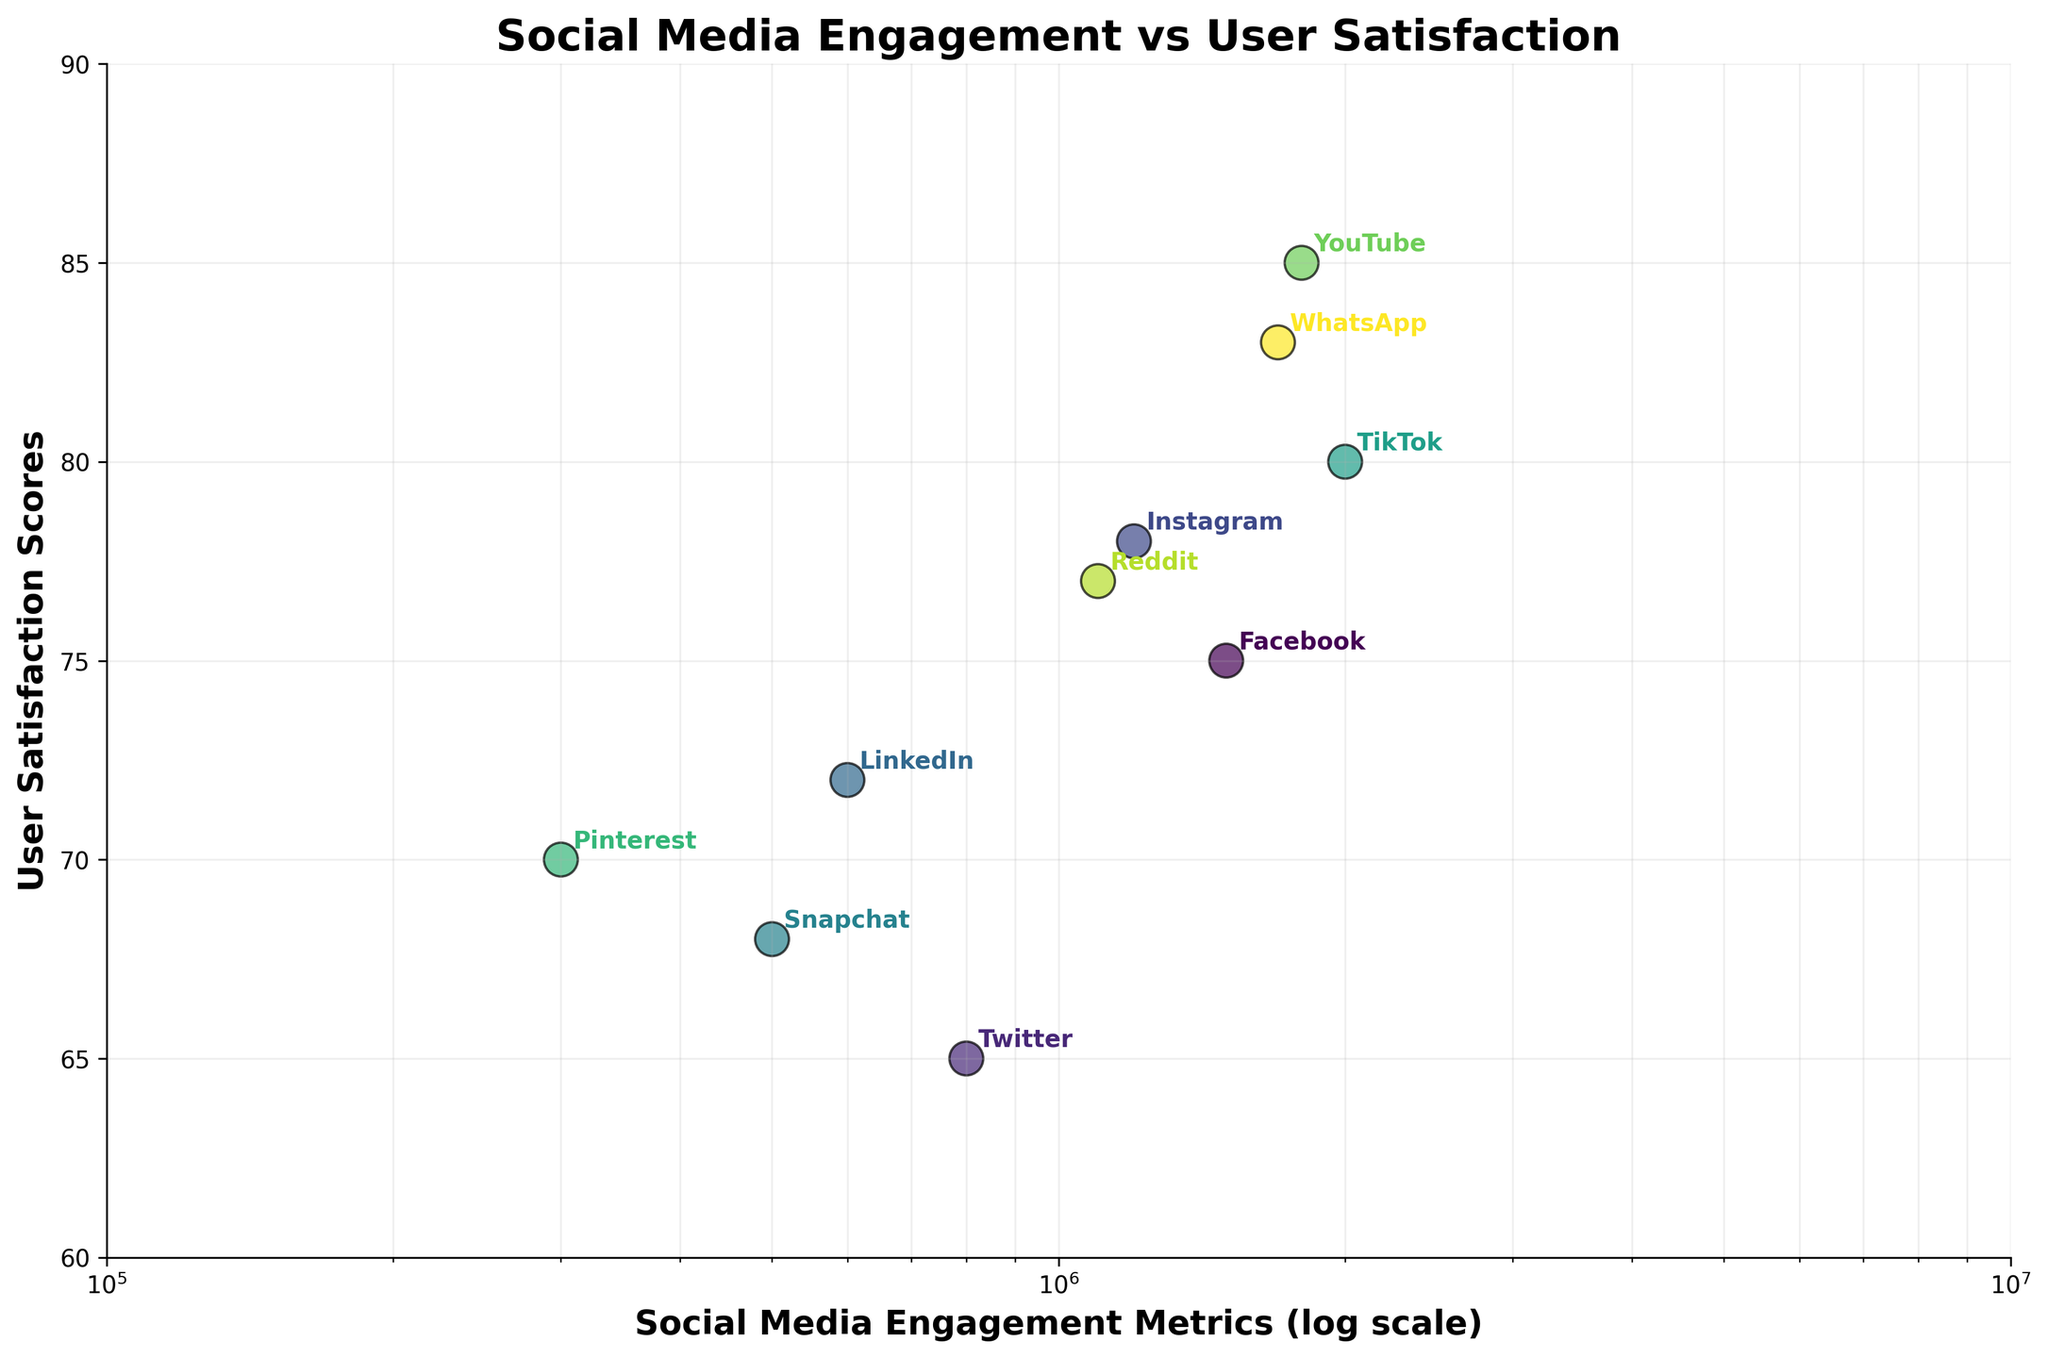What is the title of the scatter plot? The title is prominently placed at the top of the figure and is written in bold font.
Answer: Social Media Engagement vs User Satisfaction How many data points are represented in the scatter plot? Each data point corresponds to one platform, and there are annotations for each point indicating the platform names. By counting these annotations, we can determine the number of data points.
Answer: 10 Which platform has the highest User Satisfaction Score? Looking at the y-axis (User Satisfaction Scores) and identifying the data point positioned highest along this axis, with the corresponding annotation showing the platform name.
Answer: YouTube What are the x and y-axis labels? The axis labels are located along the respective axes and are written in bold font. The x-axis is labeled 'Social Media Engagement Metrics (log scale)' and the y-axis is labeled 'User Satisfaction Scores'.
Answer: Social Media Engagement Metrics (log scale); User Satisfaction Scores Which platform has the lowest Social Media Engagement Metrics? Observing the x-axis and identifying the data point positioned furthest to the left along this axis, with the corresponding annotation showing the platform name.
Answer: Pinterest Which two platforms have the closest User Satisfaction Scores? Reviewing the vertical positions of the data points and identifying two points that are closest to each other in the y-axis direction.
Answer: LinkedIn and Pinterest What is the range of the x-axis in the scatter plot? The x-axis limits are specified by the plot's bounds, ranging from just under the first tick mark to just above the last tick mark. The x-axis is scaled logarithmically, so the actual range spans from 100,000 to 10,000,000.
Answer: 100,000 to 10,000,000 How does the User Satisfaction Score for Instagram compare to Snapchat? Identifying the y-axis values for Instagram and Snapchat and comparing their heights to determine which score is higher.
Answer: Instagram is higher Which platform is positioned closest to the center of the scatter plot? Finding the data point that falls near the center of the plot area, considering both x (log scale) and y values.
Answer: Instagram Are there any platforms with a User Satisfaction Score below 70? Observing the y-axis and identifying any data points below the 70-mark, checking the corresponding annotations for platform names.
Answer: Yes, Twitter and Snapchat 